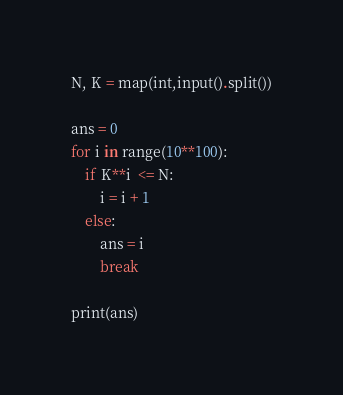<code> <loc_0><loc_0><loc_500><loc_500><_Python_>N, K = map(int,input().split())

ans = 0
for i in range(10**100):
    if K**i  <= N:
        i = i + 1
    else:
        ans = i
        break
        
print(ans)</code> 